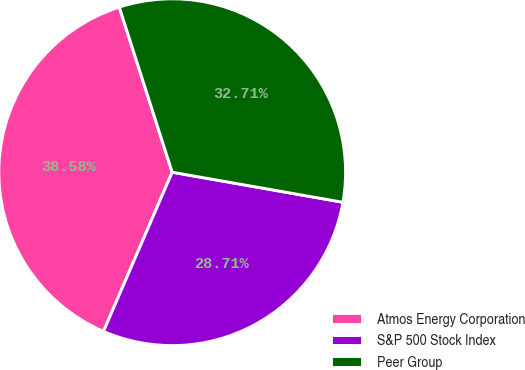Convert chart to OTSL. <chart><loc_0><loc_0><loc_500><loc_500><pie_chart><fcel>Atmos Energy Corporation<fcel>S&P 500 Stock Index<fcel>Peer Group<nl><fcel>38.58%<fcel>28.71%<fcel>32.71%<nl></chart> 